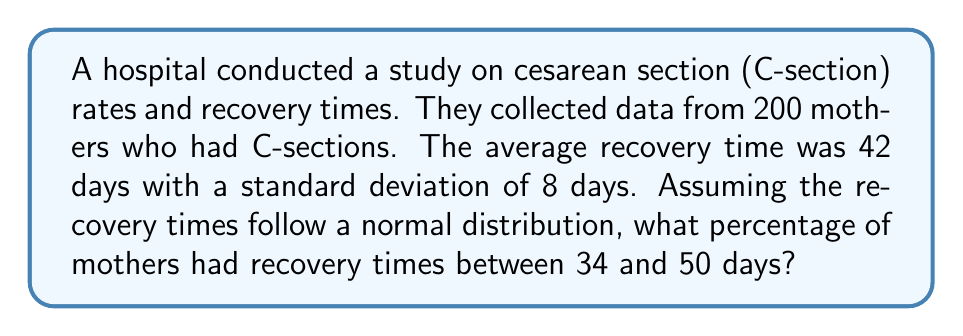Help me with this question. To solve this problem, we need to use the properties of the normal distribution and the concept of z-scores.

1. First, let's identify the given information:
   - Mean (μ) = 42 days
   - Standard deviation (σ) = 8 days
   - We want to find the percentage between 34 and 50 days

2. Calculate the z-scores for both endpoints:
   For 34 days: $z_1 = \frac{x - \mu}{\sigma} = \frac{34 - 42}{8} = -1$
   For 50 days: $z_2 = \frac{x - \mu}{\sigma} = \frac{50 - 42}{8} = 1$

3. Now, we need to find the area under the standard normal curve between z = -1 and z = 1.

4. Using a standard normal distribution table or calculator:
   P(z < 1) = 0.8413
   P(z < -1) = 0.1587

5. The area between z = -1 and z = 1 is:
   P(-1 < z < 1) = P(z < 1) - P(z < -1)
                 = 0.8413 - 0.1587
                 = 0.6826

6. Convert to percentage:
   0.6826 * 100 = 68.26%

Therefore, approximately 68.26% of mothers had recovery times between 34 and 50 days.
Answer: 68.26% 